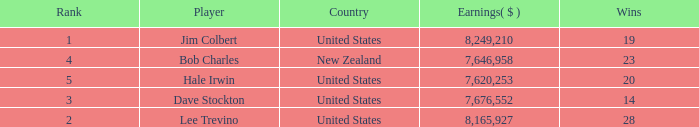How much have players earned with 14 wins ranked below 3? 0.0. 